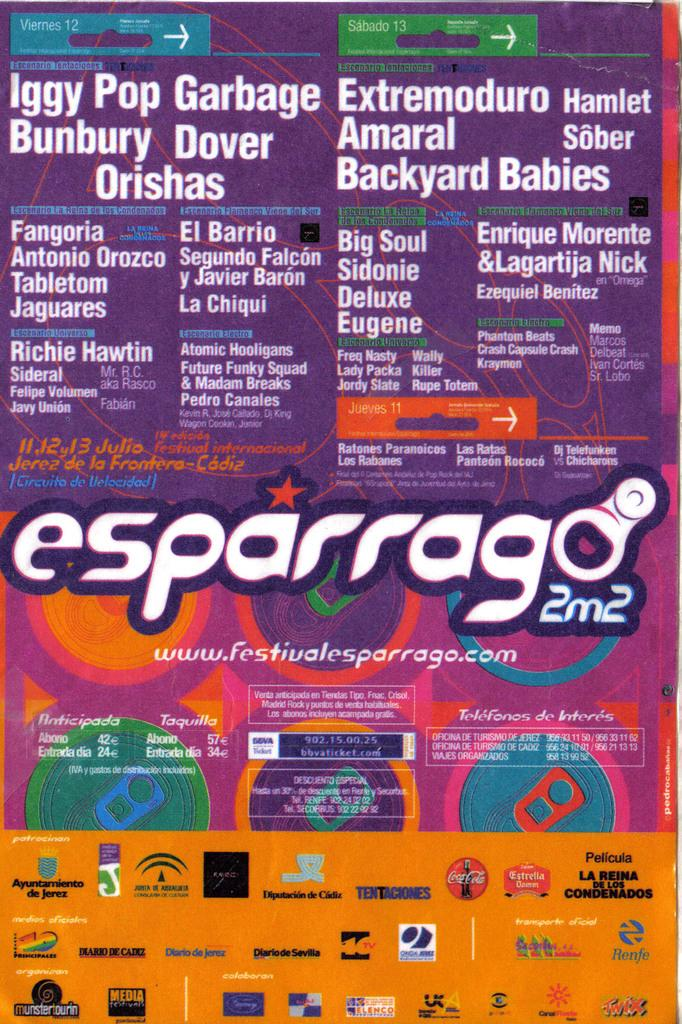<image>
Provide a brief description of the given image. A display referencing several bands including Iggy Pop and Garbage. 